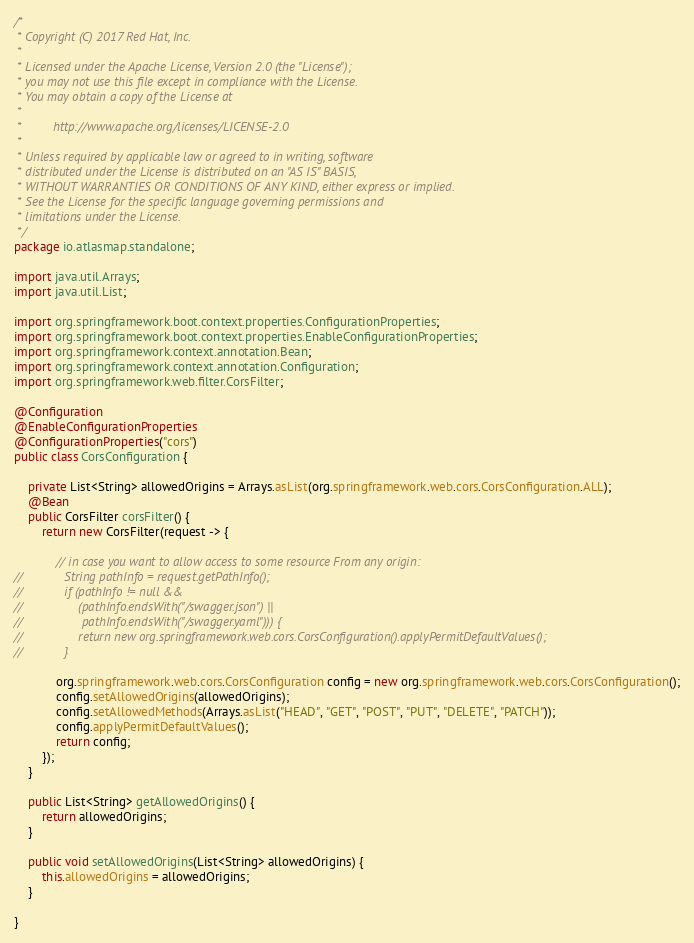<code> <loc_0><loc_0><loc_500><loc_500><_Java_>/*
 * Copyright (C) 2017 Red Hat, Inc.
 *
 * Licensed under the Apache License, Version 2.0 (the "License");
 * you may not use this file except in compliance with the License.
 * You may obtain a copy of the License at
 *
 *         http://www.apache.org/licenses/LICENSE-2.0
 *
 * Unless required by applicable law or agreed to in writing, software
 * distributed under the License is distributed on an "AS IS" BASIS,
 * WITHOUT WARRANTIES OR CONDITIONS OF ANY KIND, either express or implied.
 * See the License for the specific language governing permissions and
 * limitations under the License.
 */
package io.atlasmap.standalone;

import java.util.Arrays;
import java.util.List;

import org.springframework.boot.context.properties.ConfigurationProperties;
import org.springframework.boot.context.properties.EnableConfigurationProperties;
import org.springframework.context.annotation.Bean;
import org.springframework.context.annotation.Configuration;
import org.springframework.web.filter.CorsFilter;

@Configuration
@EnableConfigurationProperties
@ConfigurationProperties("cors")
public class CorsConfiguration {

    private List<String> allowedOrigins = Arrays.asList(org.springframework.web.cors.CorsConfiguration.ALL);
    @Bean
    public CorsFilter corsFilter() {
        return new CorsFilter(request -> {

            // in case you want to allow access to some resource From any origin:
//            String pathInfo = request.getPathInfo();
//            if (pathInfo != null &&
//                (pathInfo.endsWith("/swagger.json") ||
//                 pathInfo.endsWith("/swagger.yaml"))) {
//                return new org.springframework.web.cors.CorsConfiguration().applyPermitDefaultValues();
//            }

            org.springframework.web.cors.CorsConfiguration config = new org.springframework.web.cors.CorsConfiguration();
            config.setAllowedOrigins(allowedOrigins);
            config.setAllowedMethods(Arrays.asList("HEAD", "GET", "POST", "PUT", "DELETE", "PATCH"));
            config.applyPermitDefaultValues();
            return config;
        });
    }

    public List<String> getAllowedOrigins() {
        return allowedOrigins;
    }

    public void setAllowedOrigins(List<String> allowedOrigins) {
        this.allowedOrigins = allowedOrigins;
    }

}
</code> 